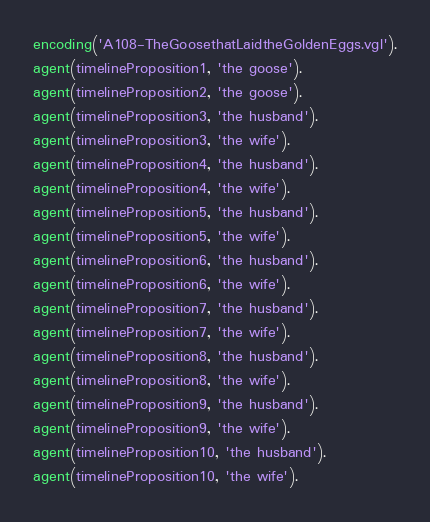<code> <loc_0><loc_0><loc_500><loc_500><_Prolog_>encoding('A108-TheGoosethatLaidtheGoldenEggs.vgl').
agent(timelineProposition1, 'the goose').
agent(timelineProposition2, 'the goose').
agent(timelineProposition3, 'the husband').
agent(timelineProposition3, 'the wife').
agent(timelineProposition4, 'the husband').
agent(timelineProposition4, 'the wife').
agent(timelineProposition5, 'the husband').
agent(timelineProposition5, 'the wife').
agent(timelineProposition6, 'the husband').
agent(timelineProposition6, 'the wife').
agent(timelineProposition7, 'the husband').
agent(timelineProposition7, 'the wife').
agent(timelineProposition8, 'the husband').
agent(timelineProposition8, 'the wife').
agent(timelineProposition9, 'the husband').
agent(timelineProposition9, 'the wife').
agent(timelineProposition10, 'the husband').
agent(timelineProposition10, 'the wife').</code> 